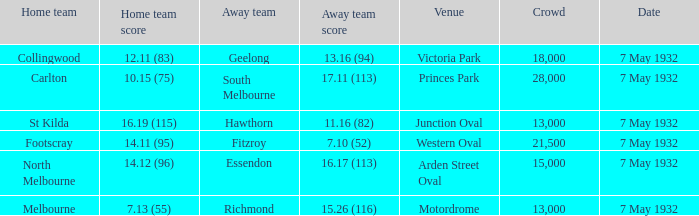What is the sum of the crowd when the home team scores 1 15000.0. 